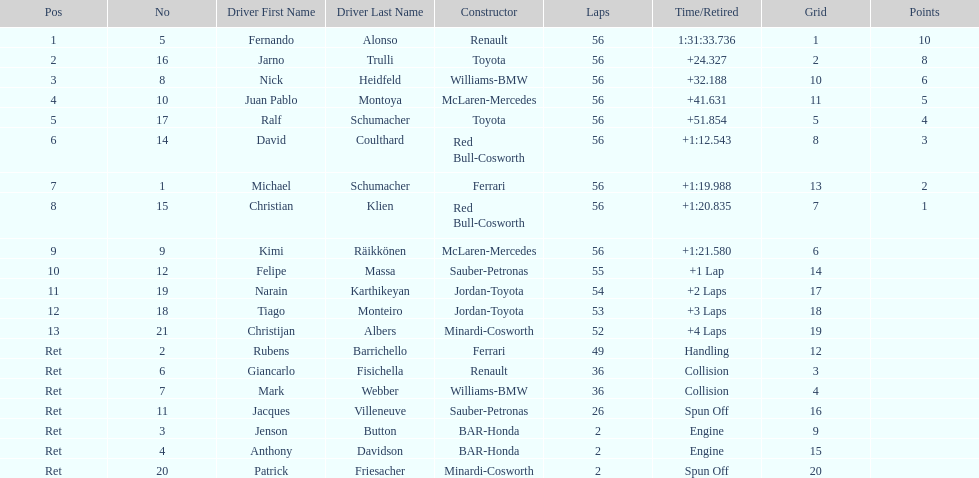How many bmws finished before webber? 1. 